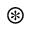Convert formula to latex. <formula><loc_0><loc_0><loc_500><loc_500>\circledast</formula> 